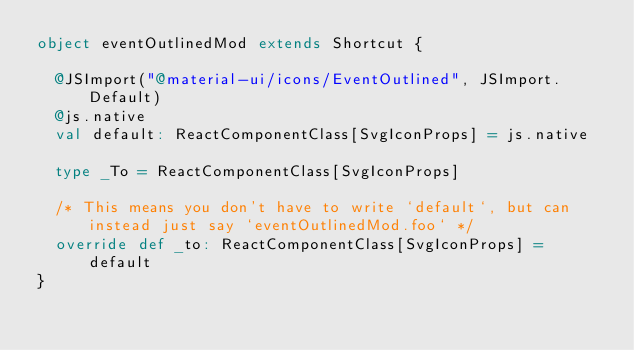<code> <loc_0><loc_0><loc_500><loc_500><_Scala_>object eventOutlinedMod extends Shortcut {
  
  @JSImport("@material-ui/icons/EventOutlined", JSImport.Default)
  @js.native
  val default: ReactComponentClass[SvgIconProps] = js.native
  
  type _To = ReactComponentClass[SvgIconProps]
  
  /* This means you don't have to write `default`, but can instead just say `eventOutlinedMod.foo` */
  override def _to: ReactComponentClass[SvgIconProps] = default
}
</code> 